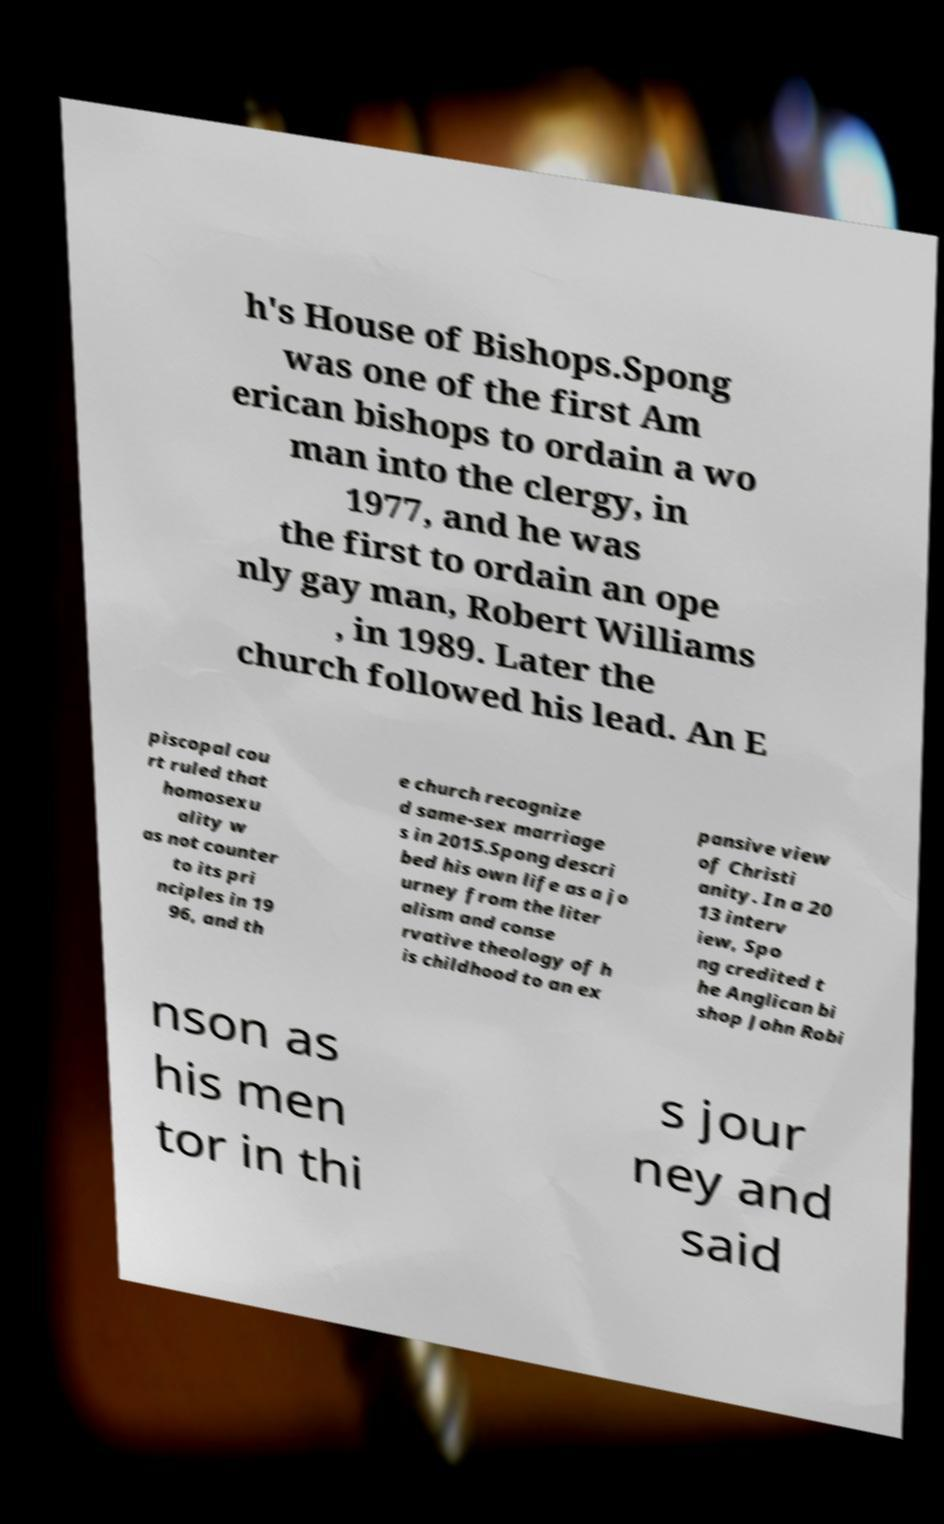Could you extract and type out the text from this image? h's House of Bishops.Spong was one of the first Am erican bishops to ordain a wo man into the clergy, in 1977, and he was the first to ordain an ope nly gay man, Robert Williams , in 1989. Later the church followed his lead. An E piscopal cou rt ruled that homosexu ality w as not counter to its pri nciples in 19 96, and th e church recognize d same-sex marriage s in 2015.Spong descri bed his own life as a jo urney from the liter alism and conse rvative theology of h is childhood to an ex pansive view of Christi anity. In a 20 13 interv iew, Spo ng credited t he Anglican bi shop John Robi nson as his men tor in thi s jour ney and said 